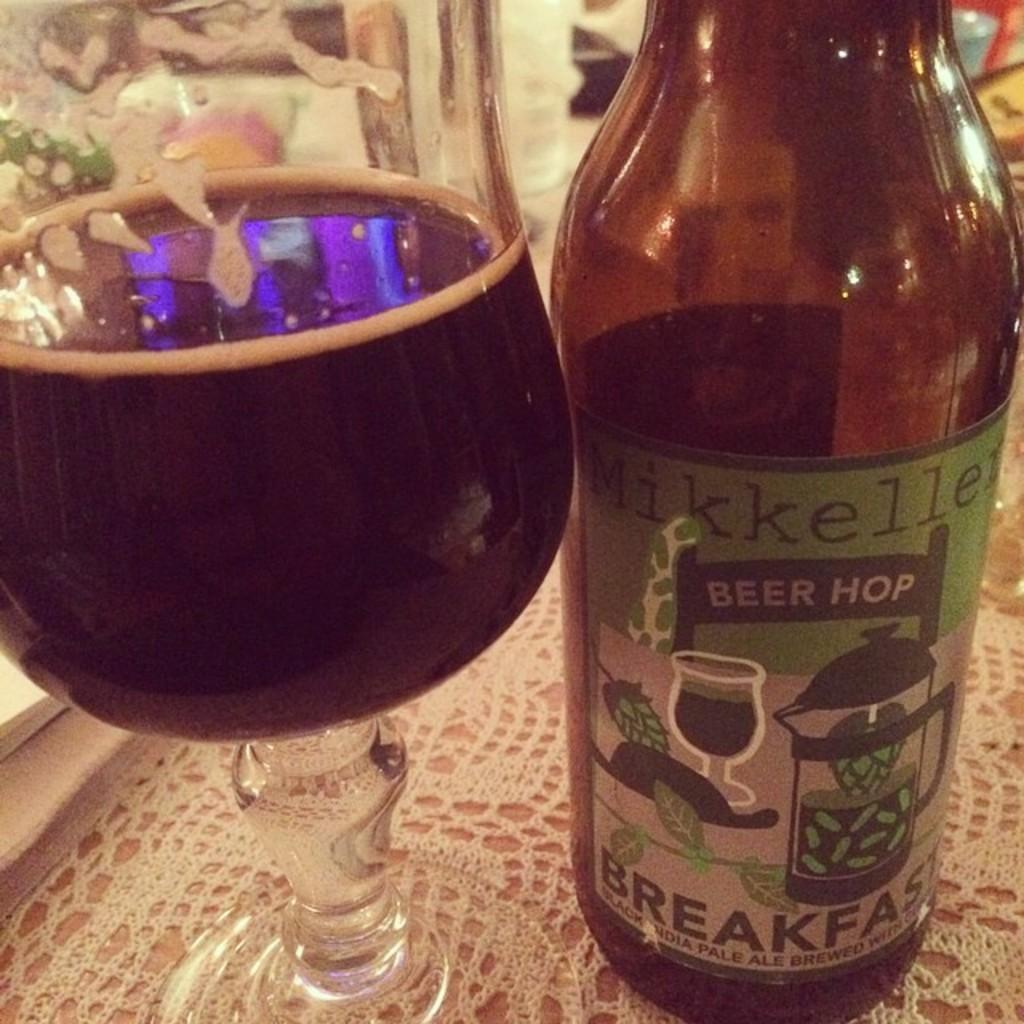<image>
Give a short and clear explanation of the subsequent image. a bottle and glass of Mikkellen Beer Hop pale ale 